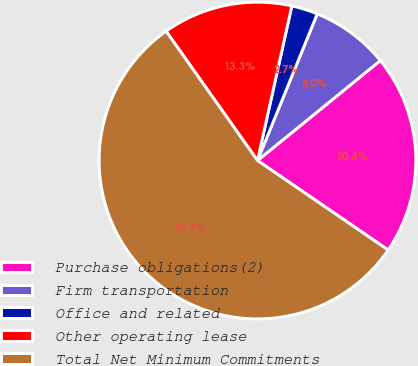Convert chart to OTSL. <chart><loc_0><loc_0><loc_500><loc_500><pie_chart><fcel>Purchase obligations(2)<fcel>Firm transportation<fcel>Office and related<fcel>Other operating lease<fcel>Total Net Minimum Commitments<nl><fcel>20.43%<fcel>7.97%<fcel>2.68%<fcel>13.27%<fcel>55.65%<nl></chart> 